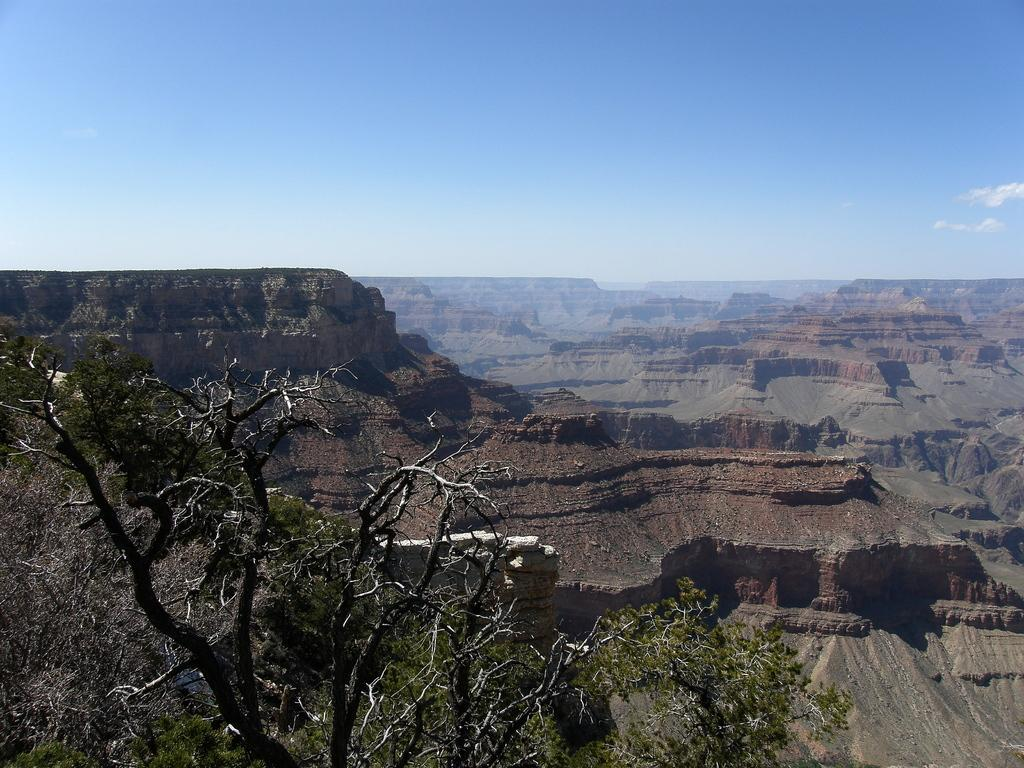What type of surface can be seen in the image? There is ground visible in the image. What type of vegetation is present in the image? There is a dry tree in the image. What is visible in the background of the image? The sky is visible in the image. What can be observed in the sky? Clouds are present in the sky. What type of grass is being digested by the airplane in the image? There is no airplane or grass present in the image, so it is not possible to answer that question. 